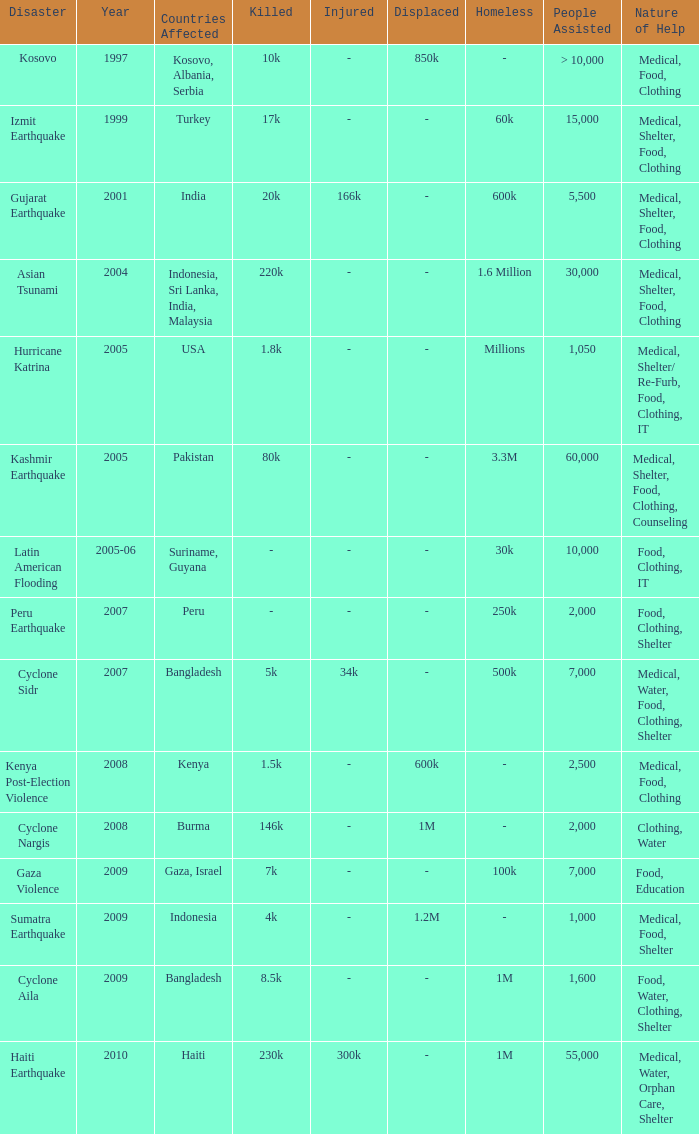Which year did USA undergo a disaster? 2005.0. 